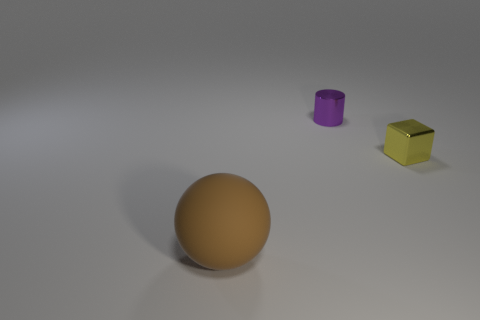Add 3 brown rubber objects. How many objects exist? 6 Subtract all balls. How many objects are left? 2 Subtract all tiny blue matte things. Subtract all yellow metal blocks. How many objects are left? 2 Add 2 small shiny cylinders. How many small shiny cylinders are left? 3 Add 2 small metallic cubes. How many small metallic cubes exist? 3 Subtract 0 cyan balls. How many objects are left? 3 